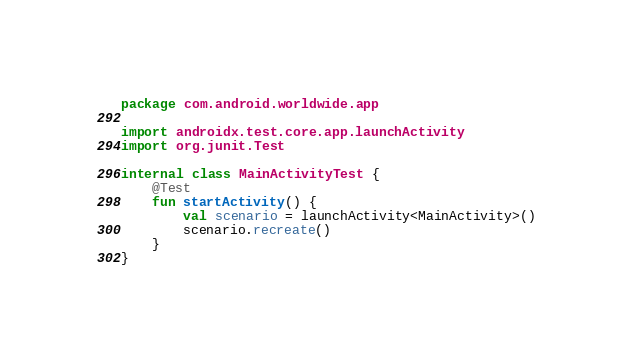<code> <loc_0><loc_0><loc_500><loc_500><_Kotlin_>package com.android.worldwide.app

import androidx.test.core.app.launchActivity
import org.junit.Test

internal class MainActivityTest {
    @Test
    fun startActivity() {
        val scenario = launchActivity<MainActivity>()
        scenario.recreate()
    }
}
</code> 